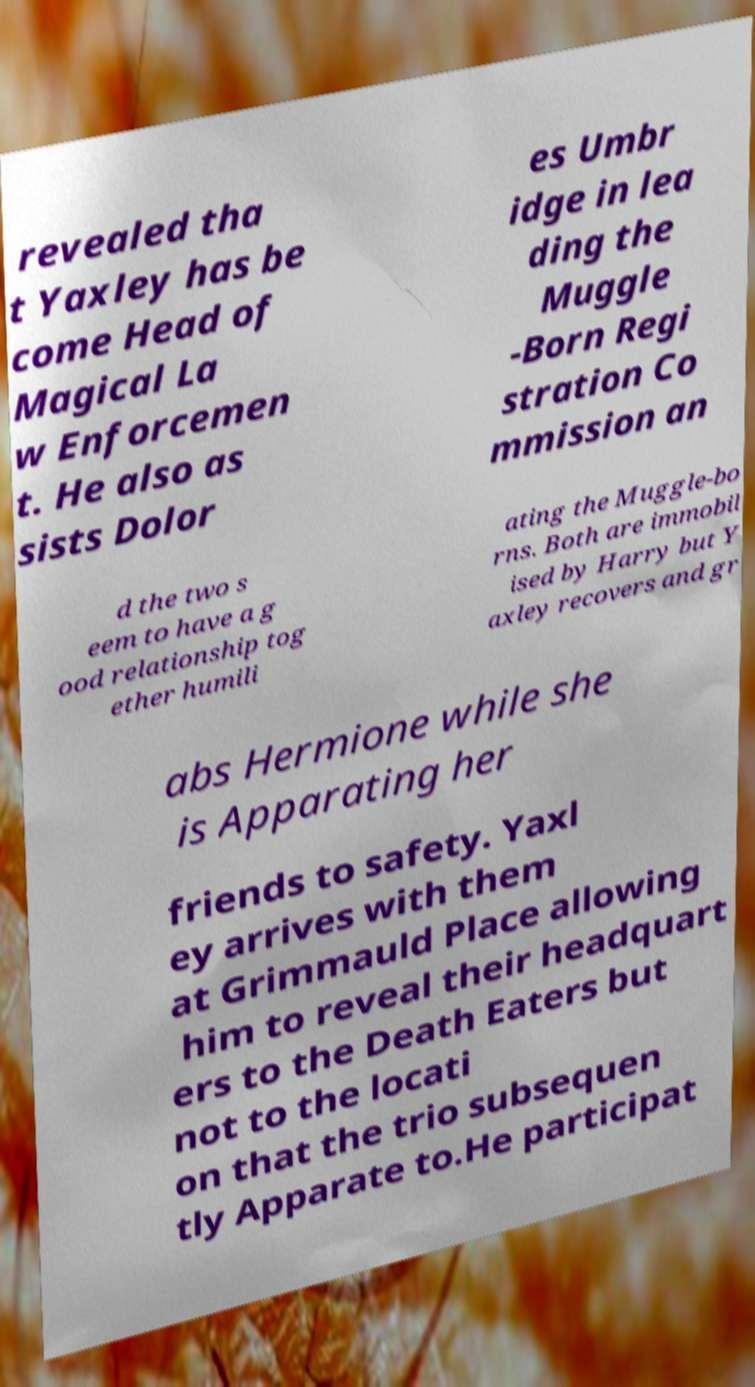I need the written content from this picture converted into text. Can you do that? revealed tha t Yaxley has be come Head of Magical La w Enforcemen t. He also as sists Dolor es Umbr idge in lea ding the Muggle -Born Regi stration Co mmission an d the two s eem to have a g ood relationship tog ether humili ating the Muggle-bo rns. Both are immobil ised by Harry but Y axley recovers and gr abs Hermione while she is Apparating her friends to safety. Yaxl ey arrives with them at Grimmauld Place allowing him to reveal their headquart ers to the Death Eaters but not to the locati on that the trio subsequen tly Apparate to.He participat 